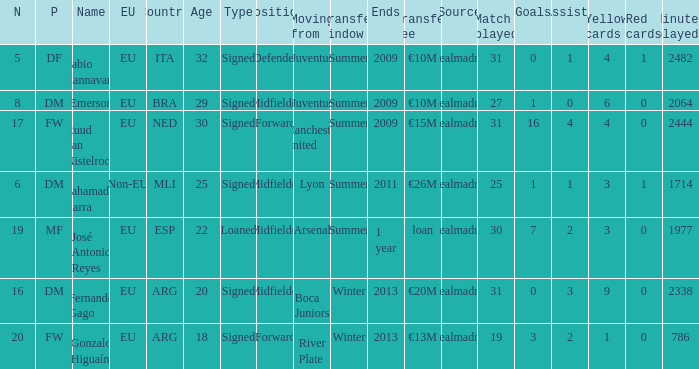How many numbers are ending in 1 year? 1.0. 